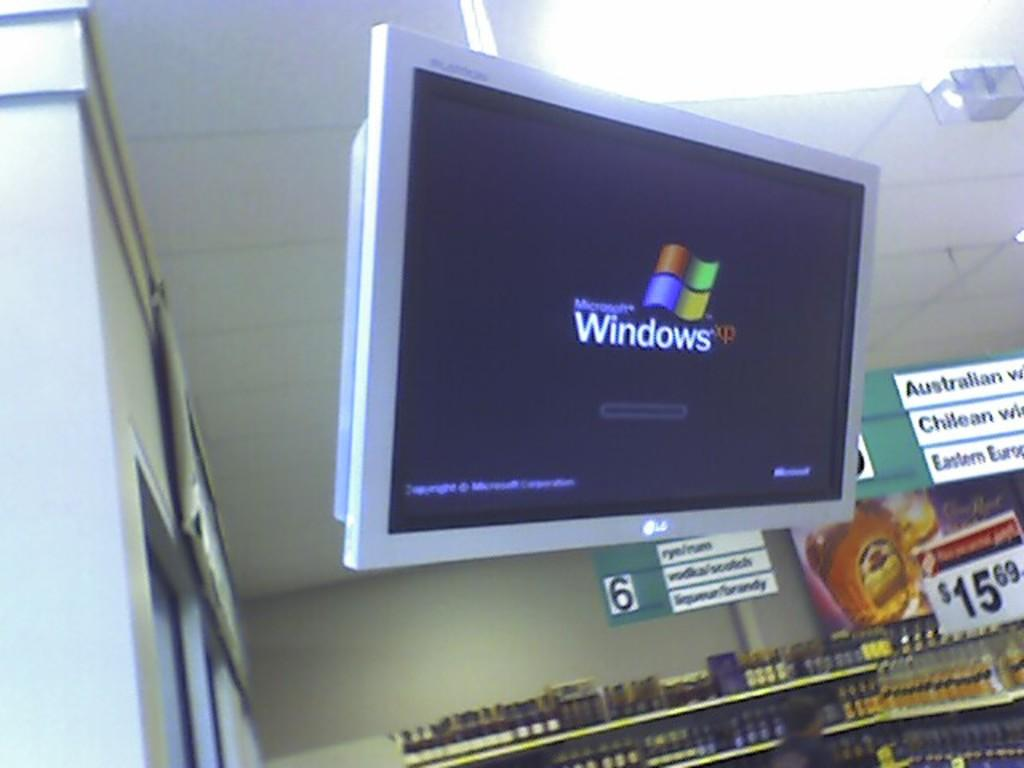<image>
Relay a brief, clear account of the picture shown. a screen that has Windows XP on it 